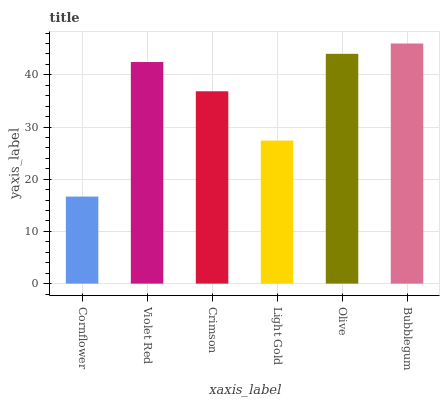Is Cornflower the minimum?
Answer yes or no. Yes. Is Bubblegum the maximum?
Answer yes or no. Yes. Is Violet Red the minimum?
Answer yes or no. No. Is Violet Red the maximum?
Answer yes or no. No. Is Violet Red greater than Cornflower?
Answer yes or no. Yes. Is Cornflower less than Violet Red?
Answer yes or no. Yes. Is Cornflower greater than Violet Red?
Answer yes or no. No. Is Violet Red less than Cornflower?
Answer yes or no. No. Is Violet Red the high median?
Answer yes or no. Yes. Is Crimson the low median?
Answer yes or no. Yes. Is Crimson the high median?
Answer yes or no. No. Is Olive the low median?
Answer yes or no. No. 